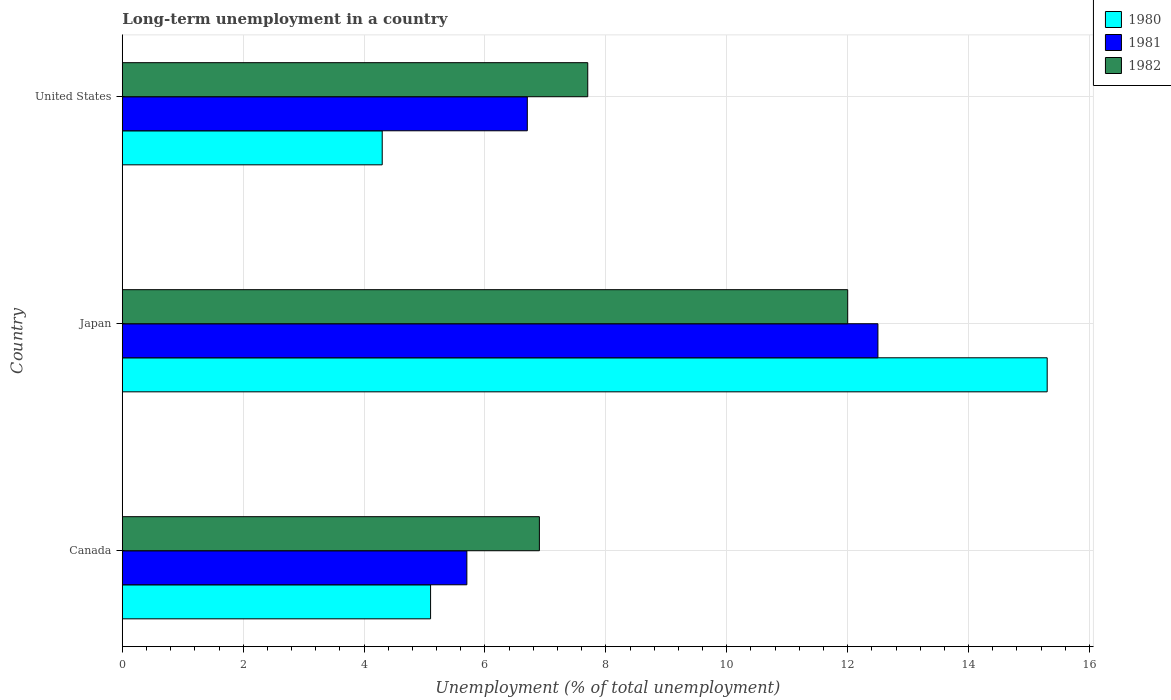How many groups of bars are there?
Offer a very short reply. 3. Are the number of bars per tick equal to the number of legend labels?
Provide a succinct answer. Yes. How many bars are there on the 2nd tick from the top?
Your answer should be very brief. 3. What is the label of the 3rd group of bars from the top?
Ensure brevity in your answer.  Canada. In how many cases, is the number of bars for a given country not equal to the number of legend labels?
Your answer should be very brief. 0. What is the percentage of long-term unemployed population in 1981 in United States?
Give a very brief answer. 6.7. Across all countries, what is the maximum percentage of long-term unemployed population in 1981?
Your response must be concise. 12.5. Across all countries, what is the minimum percentage of long-term unemployed population in 1981?
Your answer should be compact. 5.7. In which country was the percentage of long-term unemployed population in 1982 maximum?
Offer a terse response. Japan. In which country was the percentage of long-term unemployed population in 1980 minimum?
Your answer should be very brief. United States. What is the total percentage of long-term unemployed population in 1981 in the graph?
Give a very brief answer. 24.9. What is the difference between the percentage of long-term unemployed population in 1981 in Canada and that in United States?
Make the answer very short. -1. What is the average percentage of long-term unemployed population in 1982 per country?
Give a very brief answer. 8.87. What is the difference between the percentage of long-term unemployed population in 1982 and percentage of long-term unemployed population in 1981 in Canada?
Your response must be concise. 1.2. In how many countries, is the percentage of long-term unemployed population in 1982 greater than 10 %?
Provide a succinct answer. 1. What is the ratio of the percentage of long-term unemployed population in 1982 in Japan to that in United States?
Offer a terse response. 1.56. Is the percentage of long-term unemployed population in 1980 in Japan less than that in United States?
Ensure brevity in your answer.  No. Is the difference between the percentage of long-term unemployed population in 1982 in Japan and United States greater than the difference between the percentage of long-term unemployed population in 1981 in Japan and United States?
Provide a succinct answer. No. What is the difference between the highest and the second highest percentage of long-term unemployed population in 1982?
Ensure brevity in your answer.  4.3. What is the difference between the highest and the lowest percentage of long-term unemployed population in 1981?
Ensure brevity in your answer.  6.8. In how many countries, is the percentage of long-term unemployed population in 1982 greater than the average percentage of long-term unemployed population in 1982 taken over all countries?
Your answer should be compact. 1. Is the sum of the percentage of long-term unemployed population in 1981 in Canada and Japan greater than the maximum percentage of long-term unemployed population in 1980 across all countries?
Your answer should be very brief. Yes. What does the 2nd bar from the top in Canada represents?
Keep it short and to the point. 1981. Is it the case that in every country, the sum of the percentage of long-term unemployed population in 1982 and percentage of long-term unemployed population in 1981 is greater than the percentage of long-term unemployed population in 1980?
Provide a succinct answer. Yes. How many bars are there?
Your answer should be compact. 9. Are all the bars in the graph horizontal?
Offer a terse response. Yes. How many countries are there in the graph?
Offer a very short reply. 3. What is the difference between two consecutive major ticks on the X-axis?
Ensure brevity in your answer.  2. Does the graph contain any zero values?
Provide a short and direct response. No. Does the graph contain grids?
Provide a short and direct response. Yes. What is the title of the graph?
Your answer should be very brief. Long-term unemployment in a country. What is the label or title of the X-axis?
Your response must be concise. Unemployment (% of total unemployment). What is the label or title of the Y-axis?
Your response must be concise. Country. What is the Unemployment (% of total unemployment) of 1980 in Canada?
Keep it short and to the point. 5.1. What is the Unemployment (% of total unemployment) of 1981 in Canada?
Offer a terse response. 5.7. What is the Unemployment (% of total unemployment) of 1982 in Canada?
Your answer should be very brief. 6.9. What is the Unemployment (% of total unemployment) in 1980 in Japan?
Your response must be concise. 15.3. What is the Unemployment (% of total unemployment) in 1982 in Japan?
Your answer should be compact. 12. What is the Unemployment (% of total unemployment) in 1980 in United States?
Offer a terse response. 4.3. What is the Unemployment (% of total unemployment) of 1981 in United States?
Keep it short and to the point. 6.7. What is the Unemployment (% of total unemployment) of 1982 in United States?
Your answer should be compact. 7.7. Across all countries, what is the maximum Unemployment (% of total unemployment) in 1980?
Your response must be concise. 15.3. Across all countries, what is the minimum Unemployment (% of total unemployment) of 1980?
Give a very brief answer. 4.3. Across all countries, what is the minimum Unemployment (% of total unemployment) in 1981?
Your answer should be very brief. 5.7. Across all countries, what is the minimum Unemployment (% of total unemployment) of 1982?
Your response must be concise. 6.9. What is the total Unemployment (% of total unemployment) of 1980 in the graph?
Offer a very short reply. 24.7. What is the total Unemployment (% of total unemployment) in 1981 in the graph?
Offer a terse response. 24.9. What is the total Unemployment (% of total unemployment) in 1982 in the graph?
Provide a short and direct response. 26.6. What is the difference between the Unemployment (% of total unemployment) in 1981 in Canada and that in Japan?
Provide a short and direct response. -6.8. What is the difference between the Unemployment (% of total unemployment) in 1980 in Canada and that in United States?
Your answer should be compact. 0.8. What is the difference between the Unemployment (% of total unemployment) of 1981 in Canada and that in United States?
Your answer should be very brief. -1. What is the difference between the Unemployment (% of total unemployment) of 1981 in Japan and that in United States?
Provide a short and direct response. 5.8. What is the difference between the Unemployment (% of total unemployment) in 1980 in Canada and the Unemployment (% of total unemployment) in 1981 in Japan?
Provide a succinct answer. -7.4. What is the difference between the Unemployment (% of total unemployment) of 1980 in Canada and the Unemployment (% of total unemployment) of 1982 in Japan?
Your answer should be compact. -6.9. What is the difference between the Unemployment (% of total unemployment) in 1980 in Canada and the Unemployment (% of total unemployment) in 1982 in United States?
Your answer should be very brief. -2.6. What is the difference between the Unemployment (% of total unemployment) of 1980 in Japan and the Unemployment (% of total unemployment) of 1982 in United States?
Provide a short and direct response. 7.6. What is the difference between the Unemployment (% of total unemployment) of 1981 in Japan and the Unemployment (% of total unemployment) of 1982 in United States?
Your response must be concise. 4.8. What is the average Unemployment (% of total unemployment) of 1980 per country?
Keep it short and to the point. 8.23. What is the average Unemployment (% of total unemployment) in 1982 per country?
Keep it short and to the point. 8.87. What is the difference between the Unemployment (% of total unemployment) of 1980 and Unemployment (% of total unemployment) of 1981 in Japan?
Offer a terse response. 2.8. What is the difference between the Unemployment (% of total unemployment) in 1980 and Unemployment (% of total unemployment) in 1982 in Japan?
Ensure brevity in your answer.  3.3. What is the difference between the Unemployment (% of total unemployment) of 1981 and Unemployment (% of total unemployment) of 1982 in Japan?
Ensure brevity in your answer.  0.5. What is the difference between the Unemployment (% of total unemployment) of 1980 and Unemployment (% of total unemployment) of 1981 in United States?
Your answer should be compact. -2.4. What is the difference between the Unemployment (% of total unemployment) of 1980 and Unemployment (% of total unemployment) of 1982 in United States?
Ensure brevity in your answer.  -3.4. What is the difference between the Unemployment (% of total unemployment) in 1981 and Unemployment (% of total unemployment) in 1982 in United States?
Keep it short and to the point. -1. What is the ratio of the Unemployment (% of total unemployment) in 1981 in Canada to that in Japan?
Your response must be concise. 0.46. What is the ratio of the Unemployment (% of total unemployment) of 1982 in Canada to that in Japan?
Your answer should be compact. 0.57. What is the ratio of the Unemployment (% of total unemployment) in 1980 in Canada to that in United States?
Provide a succinct answer. 1.19. What is the ratio of the Unemployment (% of total unemployment) of 1981 in Canada to that in United States?
Provide a short and direct response. 0.85. What is the ratio of the Unemployment (% of total unemployment) of 1982 in Canada to that in United States?
Provide a short and direct response. 0.9. What is the ratio of the Unemployment (% of total unemployment) in 1980 in Japan to that in United States?
Offer a terse response. 3.56. What is the ratio of the Unemployment (% of total unemployment) of 1981 in Japan to that in United States?
Your response must be concise. 1.87. What is the ratio of the Unemployment (% of total unemployment) of 1982 in Japan to that in United States?
Make the answer very short. 1.56. What is the difference between the highest and the second highest Unemployment (% of total unemployment) of 1981?
Your answer should be compact. 5.8. 